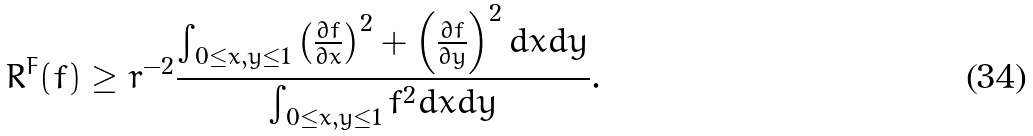Convert formula to latex. <formula><loc_0><loc_0><loc_500><loc_500>R ^ { F } ( f ) \geq r ^ { - 2 } \frac { \int _ { 0 \leq x , y \leq 1 } \left ( \frac { \partial f } { \partial x } \right ) ^ { 2 } + \left ( \frac { \partial f } { \partial y } \right ) ^ { 2 } d x d y } { \int _ { 0 \leq x , y \leq 1 } f ^ { 2 } d x d y } .</formula> 